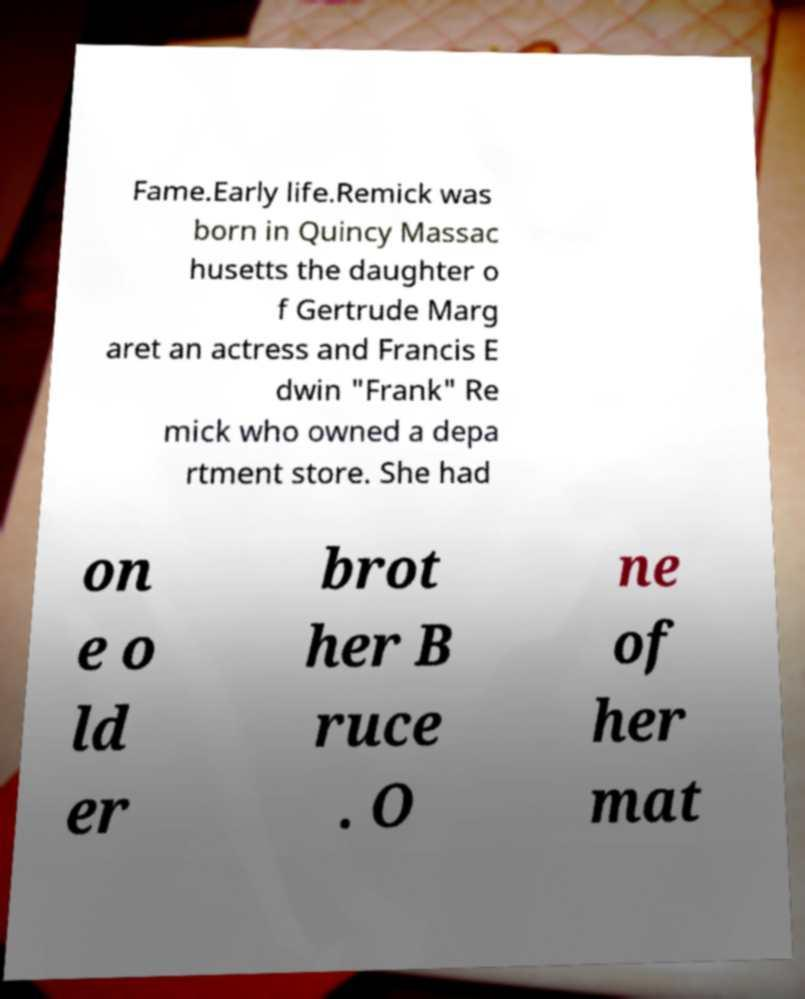Can you read and provide the text displayed in the image?This photo seems to have some interesting text. Can you extract and type it out for me? Fame.Early life.Remick was born in Quincy Massac husetts the daughter o f Gertrude Marg aret an actress and Francis E dwin "Frank" Re mick who owned a depa rtment store. She had on e o ld er brot her B ruce . O ne of her mat 